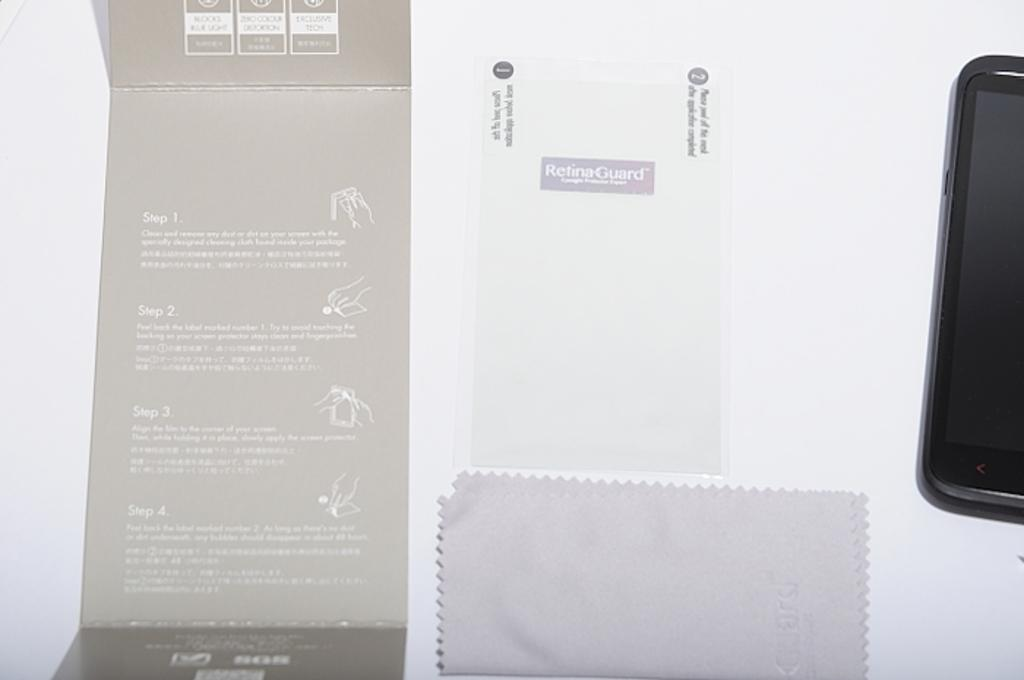<image>
Describe the image concisely. a cell phone and packaging for Retina Guard on a display table 